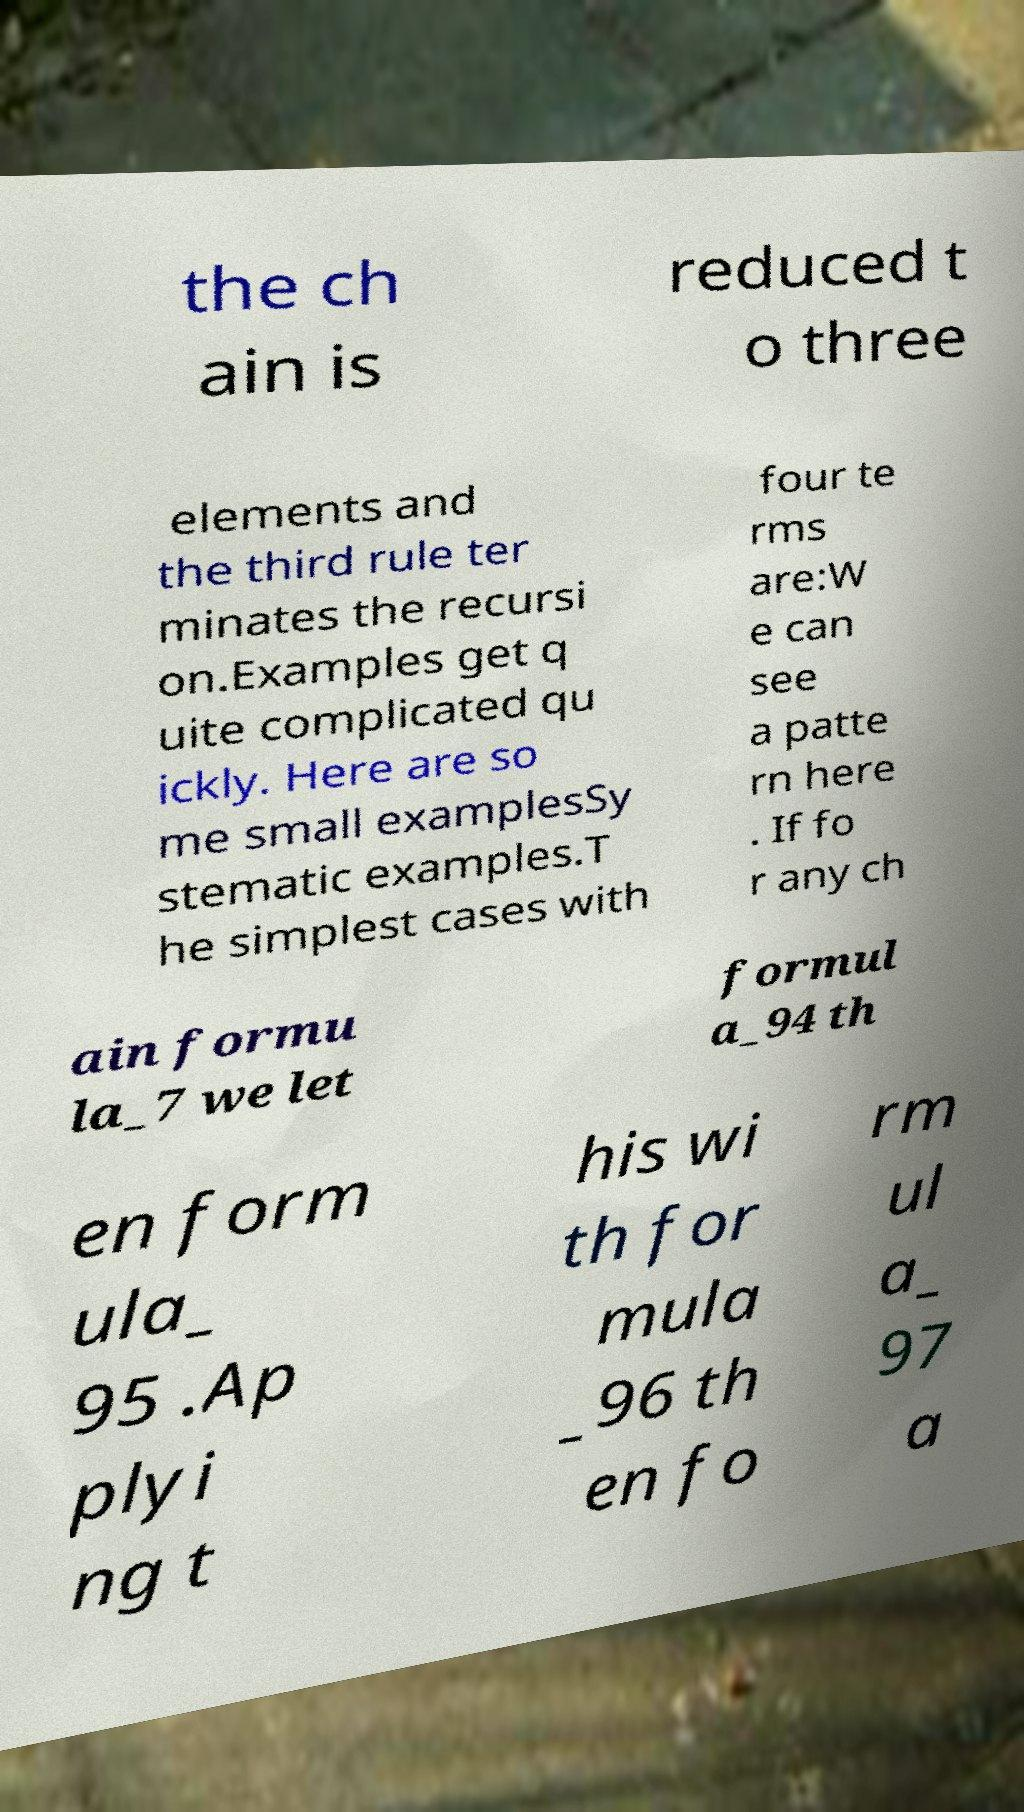Can you read and provide the text displayed in the image?This photo seems to have some interesting text. Can you extract and type it out for me? the ch ain is reduced t o three elements and the third rule ter minates the recursi on.Examples get q uite complicated qu ickly. Here are so me small examplesSy stematic examples.T he simplest cases with four te rms are:W e can see a patte rn here . If fo r any ch ain formu la_7 we let formul a_94 th en form ula_ 95 .Ap plyi ng t his wi th for mula _96 th en fo rm ul a_ 97 a 